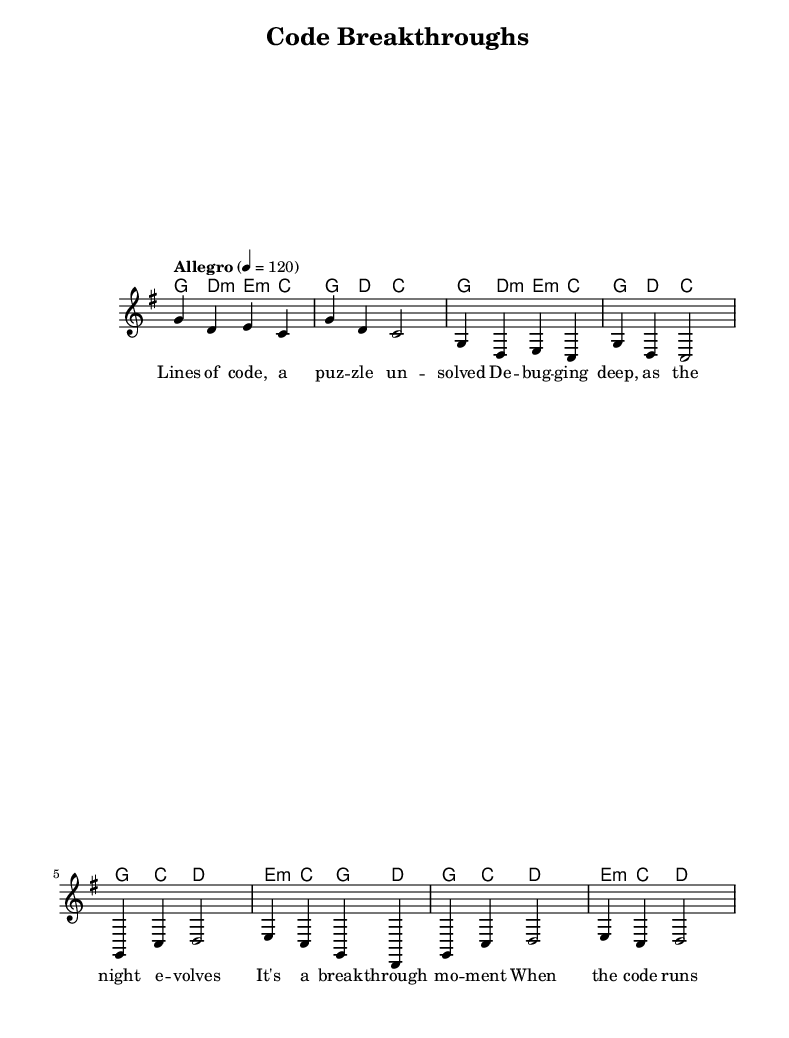What is the key signature of this music? The key signature is G major, which has one sharp (F#). This can be determined by looking for the key signature symbol located at the beginning of the staff for the music.
Answer: G major What is the time signature of the piece? The time signature is 4/4, which means there are four beats in each measure, and the quarter note receives one beat. It is indicated at the beginning of the staff, right after the key signature.
Answer: 4/4 What is the tempo marking for this piece? The tempo marking is "Allegro," which indicates a fast, lively pace for the music. The specific tempo indicated is 120 beats per minute, shown at the start of the score.
Answer: Allegro What chords are used in the chorus? The chords used in the chorus are G, C, D, and E minor, which can be found in the harmonies section listed alongside the melody. Each chord is notated above the related measures in the chorus part.
Answer: G, C, D, E minor How many measures are there in the chorus? There are four measures in the chorus, providing a complete phrase before moving on. This can be counted visually by looking at the section of the music marked as the chorus and counting the groupings of notes.
Answer: 4 What does the phrase "break-through moment" signify in this song? The phrase "break-through moment" in this folk-pop fusion context signifies a significant achievement in software development, such as completing a challenging task or solving a complex problem. This reflects the theme of the song centered on successful coding experiences.
Answer: Significant achievement How does the melody relate to the theme of the lyrics? The melody appears upbeat and flowing, which complements the positive and celebratory theme of the lyrics that discuss success and breakthroughs in coding. This contrast and interplay between the musical elements and the text adds to the overall folk-pop fusion experience.
Answer: Upbeat and flowing 